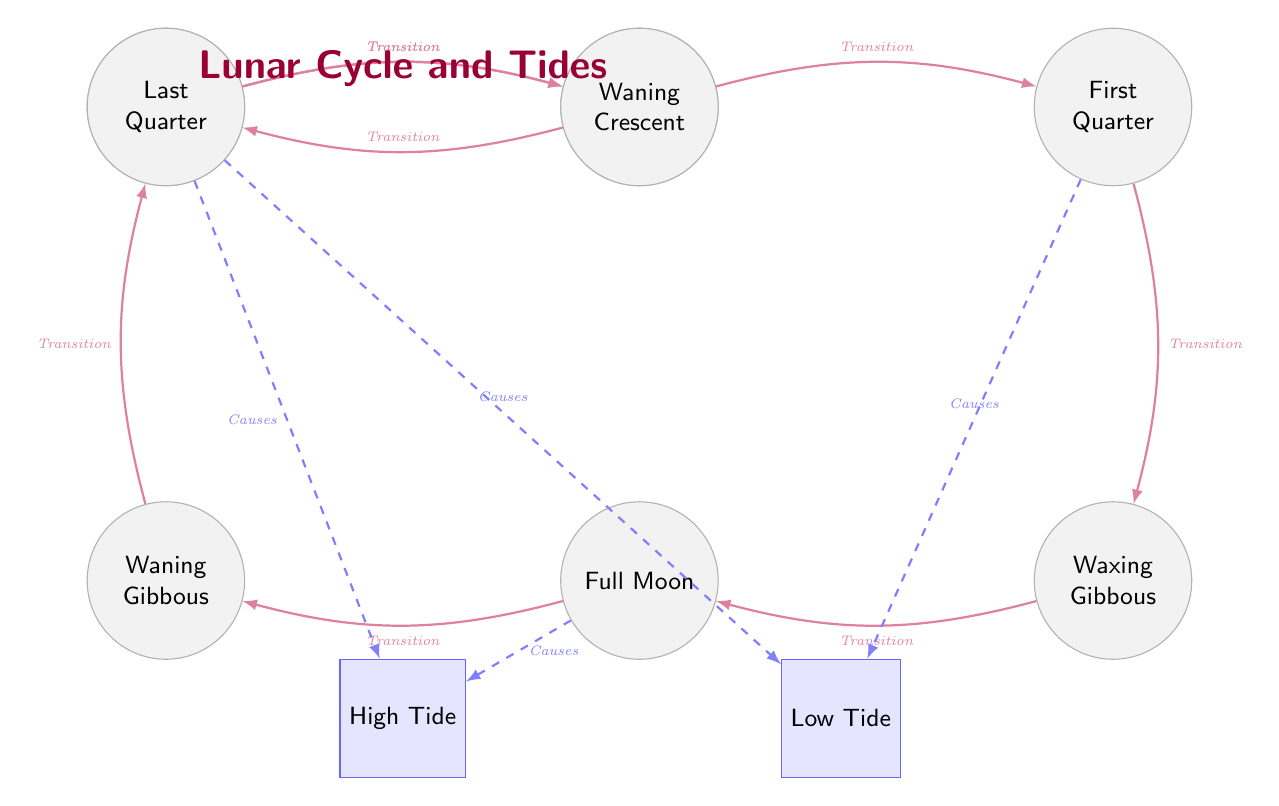What are the moon phases present in the diagram? The diagram displays seven moon phases arranged horizontally, which are: New Moon, Waxing Crescent, First Quarter, Waxing Gibbous, Full Moon, Waning Gibbous, Last Quarter, and Waning Crescent.
Answer: New Moon, Waxing Crescent, First Quarter, Waxing Gibbous, Full Moon, Waning Gibbous, Last Quarter, Waning Crescent How many types of tides are illustrated? The diagram presents two types of tides connected to the moon phases: High Tide and Low Tide.
Answer: 2 What transition occurs after the Full Moon? From the Full Moon, the transition leads to the Waning Gibbous phase, indicating a decrease in illumination.
Answer: Waning Gibbous Which moon phases lead to High Tide? High Tide is influenced by the New Moon and Full Moon phases, as indicated by the arrows pointing from these phases to the High Tide box.
Answer: New Moon, Full Moon Which transition leads to the First Quarter phase? The transition from the Waxing Crescent phase leads to the First Quarter phase, where the moon is half illuminated.
Answer: Waxing Crescent How many transitions are represented in the diagram? There are a total of eight transitions illustrated between the moon phases, as each phase flows into the next with one transition arrow.
Answer: 8 What moon phase is associated with Low Tide? The diagram notes that the Low Tide is caused by both the First Quarter and Last Quarter phases.
Answer: First Quarter, Last Quarter Which phase directly precedes the Waning Crescent? The Last Quarter phase comes just before the Waning Crescent phase in the sequence of moon phases.
Answer: Last Quarter 